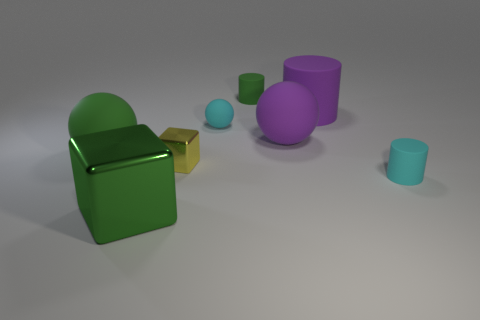What number of things are tiny yellow shiny cubes or cyan things?
Your response must be concise. 3. There is a cyan ball; is it the same size as the matte thing that is in front of the small metal thing?
Offer a very short reply. Yes. What number of other things are there of the same material as the green cylinder
Ensure brevity in your answer.  5. How many things are shiny cubes that are to the right of the large green shiny cube or cyan rubber objects behind the tiny block?
Offer a very short reply. 2. There is a large green object that is the same shape as the tiny yellow thing; what is its material?
Make the answer very short. Metal. Are any green metal cubes visible?
Make the answer very short. Yes. There is a ball that is in front of the small sphere and right of the large green shiny thing; what is its size?
Ensure brevity in your answer.  Large. What shape is the tiny green rubber thing?
Offer a very short reply. Cylinder. Is there a green rubber sphere that is behind the tiny cylinder in front of the tiny metallic thing?
Offer a terse response. Yes. What is the material of the green ball that is the same size as the purple rubber cylinder?
Give a very brief answer. Rubber. 